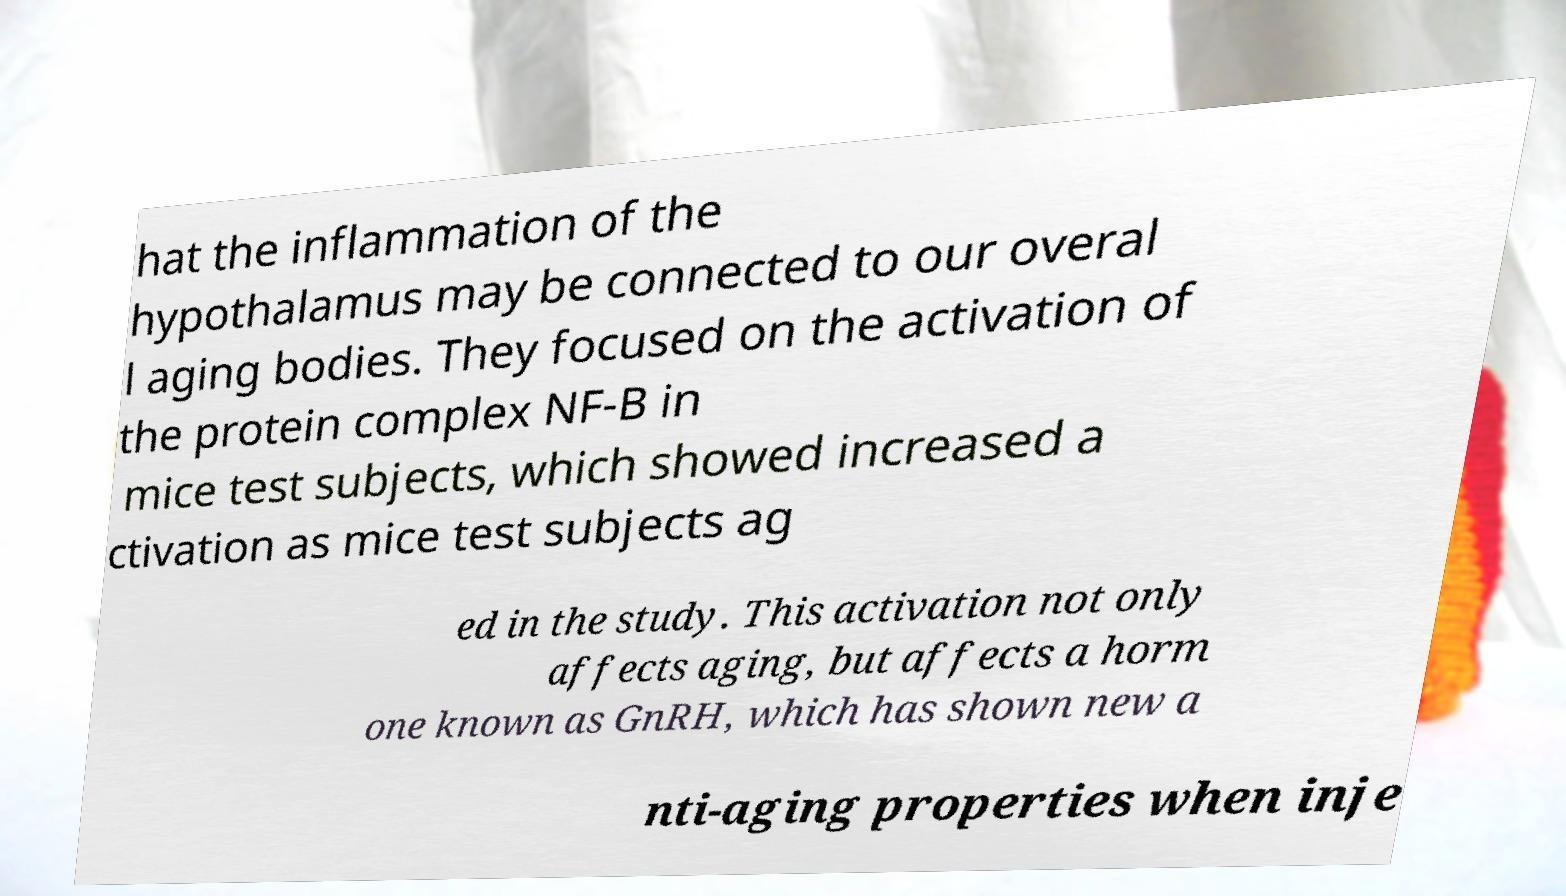Can you accurately transcribe the text from the provided image for me? hat the inflammation of the hypothalamus may be connected to our overal l aging bodies. They focused on the activation of the protein complex NF-B in mice test subjects, which showed increased a ctivation as mice test subjects ag ed in the study. This activation not only affects aging, but affects a horm one known as GnRH, which has shown new a nti-aging properties when inje 